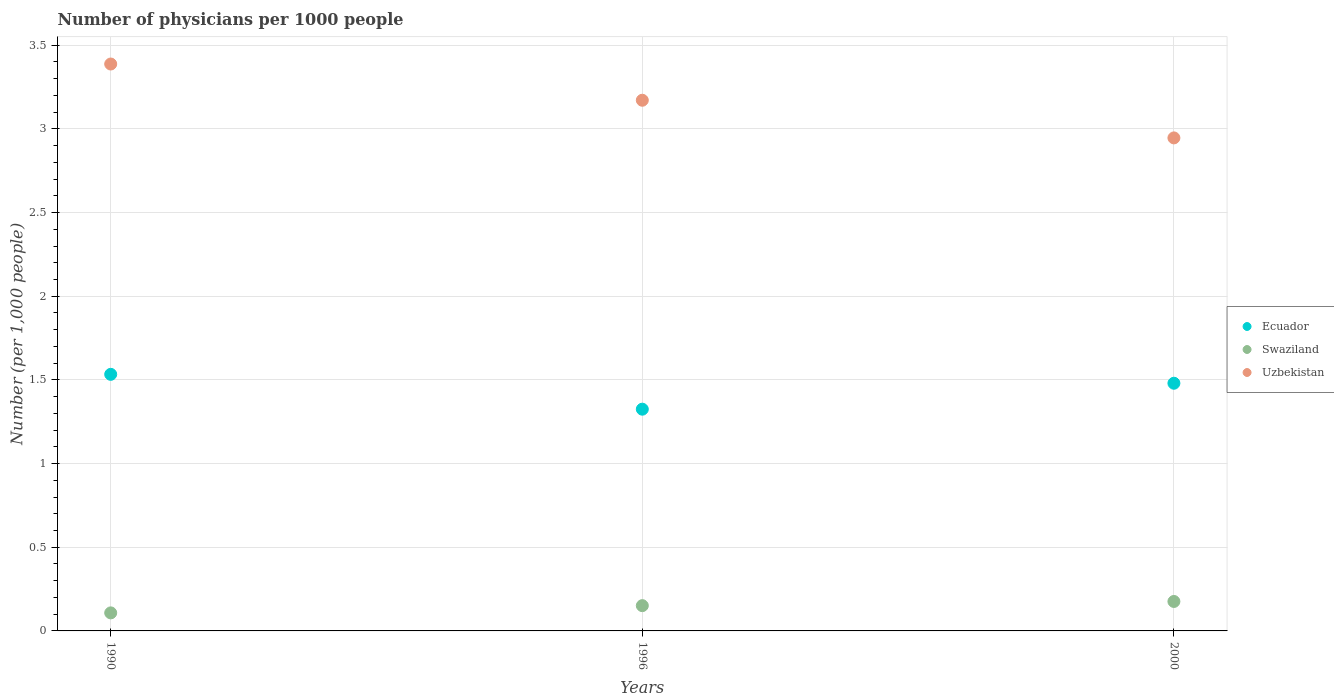How many different coloured dotlines are there?
Provide a short and direct response. 3. Is the number of dotlines equal to the number of legend labels?
Make the answer very short. Yes. What is the number of physicians in Uzbekistan in 1996?
Your answer should be very brief. 3.17. Across all years, what is the maximum number of physicians in Ecuador?
Provide a short and direct response. 1.53. Across all years, what is the minimum number of physicians in Ecuador?
Your answer should be compact. 1.32. In which year was the number of physicians in Swaziland maximum?
Give a very brief answer. 2000. What is the total number of physicians in Uzbekistan in the graph?
Make the answer very short. 9.5. What is the difference between the number of physicians in Uzbekistan in 1996 and that in 2000?
Offer a terse response. 0.22. What is the difference between the number of physicians in Swaziland in 2000 and the number of physicians in Ecuador in 1996?
Your answer should be compact. -1.15. What is the average number of physicians in Ecuador per year?
Provide a succinct answer. 1.45. In the year 1990, what is the difference between the number of physicians in Swaziland and number of physicians in Ecuador?
Your answer should be very brief. -1.43. In how many years, is the number of physicians in Uzbekistan greater than 2.7?
Your response must be concise. 3. What is the ratio of the number of physicians in Ecuador in 1996 to that in 2000?
Make the answer very short. 0.9. Is the difference between the number of physicians in Swaziland in 1990 and 1996 greater than the difference between the number of physicians in Ecuador in 1990 and 1996?
Your answer should be compact. No. What is the difference between the highest and the second highest number of physicians in Ecuador?
Provide a short and direct response. 0.05. What is the difference between the highest and the lowest number of physicians in Ecuador?
Ensure brevity in your answer.  0.21. Does the number of physicians in Swaziland monotonically increase over the years?
Offer a very short reply. Yes. Is the number of physicians in Uzbekistan strictly greater than the number of physicians in Swaziland over the years?
Your answer should be compact. Yes. Is the number of physicians in Swaziland strictly less than the number of physicians in Uzbekistan over the years?
Ensure brevity in your answer.  Yes. Does the graph contain any zero values?
Your answer should be very brief. No. Does the graph contain grids?
Give a very brief answer. Yes. Where does the legend appear in the graph?
Keep it short and to the point. Center right. What is the title of the graph?
Provide a short and direct response. Number of physicians per 1000 people. What is the label or title of the X-axis?
Your answer should be very brief. Years. What is the label or title of the Y-axis?
Your answer should be compact. Number (per 1,0 people). What is the Number (per 1,000 people) in Ecuador in 1990?
Provide a short and direct response. 1.53. What is the Number (per 1,000 people) in Swaziland in 1990?
Make the answer very short. 0.11. What is the Number (per 1,000 people) of Uzbekistan in 1990?
Provide a succinct answer. 3.39. What is the Number (per 1,000 people) in Ecuador in 1996?
Provide a short and direct response. 1.32. What is the Number (per 1,000 people) of Swaziland in 1996?
Keep it short and to the point. 0.15. What is the Number (per 1,000 people) of Uzbekistan in 1996?
Keep it short and to the point. 3.17. What is the Number (per 1,000 people) in Ecuador in 2000?
Your answer should be very brief. 1.48. What is the Number (per 1,000 people) in Swaziland in 2000?
Make the answer very short. 0.18. What is the Number (per 1,000 people) in Uzbekistan in 2000?
Give a very brief answer. 2.95. Across all years, what is the maximum Number (per 1,000 people) of Ecuador?
Your response must be concise. 1.53. Across all years, what is the maximum Number (per 1,000 people) of Swaziland?
Provide a short and direct response. 0.18. Across all years, what is the maximum Number (per 1,000 people) of Uzbekistan?
Offer a very short reply. 3.39. Across all years, what is the minimum Number (per 1,000 people) in Ecuador?
Make the answer very short. 1.32. Across all years, what is the minimum Number (per 1,000 people) of Swaziland?
Make the answer very short. 0.11. Across all years, what is the minimum Number (per 1,000 people) of Uzbekistan?
Offer a very short reply. 2.95. What is the total Number (per 1,000 people) in Ecuador in the graph?
Offer a terse response. 4.34. What is the total Number (per 1,000 people) in Swaziland in the graph?
Offer a very short reply. 0.43. What is the total Number (per 1,000 people) in Uzbekistan in the graph?
Offer a very short reply. 9.5. What is the difference between the Number (per 1,000 people) of Ecuador in 1990 and that in 1996?
Ensure brevity in your answer.  0.21. What is the difference between the Number (per 1,000 people) of Swaziland in 1990 and that in 1996?
Provide a succinct answer. -0.04. What is the difference between the Number (per 1,000 people) of Uzbekistan in 1990 and that in 1996?
Make the answer very short. 0.22. What is the difference between the Number (per 1,000 people) in Ecuador in 1990 and that in 2000?
Your response must be concise. 0.05. What is the difference between the Number (per 1,000 people) in Swaziland in 1990 and that in 2000?
Your answer should be very brief. -0.07. What is the difference between the Number (per 1,000 people) of Uzbekistan in 1990 and that in 2000?
Your answer should be very brief. 0.44. What is the difference between the Number (per 1,000 people) in Ecuador in 1996 and that in 2000?
Give a very brief answer. -0.15. What is the difference between the Number (per 1,000 people) of Swaziland in 1996 and that in 2000?
Provide a short and direct response. -0.03. What is the difference between the Number (per 1,000 people) in Uzbekistan in 1996 and that in 2000?
Your answer should be very brief. 0.23. What is the difference between the Number (per 1,000 people) in Ecuador in 1990 and the Number (per 1,000 people) in Swaziland in 1996?
Your response must be concise. 1.38. What is the difference between the Number (per 1,000 people) in Ecuador in 1990 and the Number (per 1,000 people) in Uzbekistan in 1996?
Your response must be concise. -1.64. What is the difference between the Number (per 1,000 people) in Swaziland in 1990 and the Number (per 1,000 people) in Uzbekistan in 1996?
Offer a terse response. -3.06. What is the difference between the Number (per 1,000 people) of Ecuador in 1990 and the Number (per 1,000 people) of Swaziland in 2000?
Offer a terse response. 1.36. What is the difference between the Number (per 1,000 people) of Ecuador in 1990 and the Number (per 1,000 people) of Uzbekistan in 2000?
Your answer should be compact. -1.41. What is the difference between the Number (per 1,000 people) in Swaziland in 1990 and the Number (per 1,000 people) in Uzbekistan in 2000?
Offer a very short reply. -2.84. What is the difference between the Number (per 1,000 people) in Ecuador in 1996 and the Number (per 1,000 people) in Swaziland in 2000?
Keep it short and to the point. 1.15. What is the difference between the Number (per 1,000 people) in Ecuador in 1996 and the Number (per 1,000 people) in Uzbekistan in 2000?
Offer a terse response. -1.62. What is the difference between the Number (per 1,000 people) of Swaziland in 1996 and the Number (per 1,000 people) of Uzbekistan in 2000?
Offer a very short reply. -2.79. What is the average Number (per 1,000 people) of Ecuador per year?
Your answer should be compact. 1.45. What is the average Number (per 1,000 people) of Swaziland per year?
Give a very brief answer. 0.14. What is the average Number (per 1,000 people) of Uzbekistan per year?
Keep it short and to the point. 3.17. In the year 1990, what is the difference between the Number (per 1,000 people) of Ecuador and Number (per 1,000 people) of Swaziland?
Offer a very short reply. 1.43. In the year 1990, what is the difference between the Number (per 1,000 people) in Ecuador and Number (per 1,000 people) in Uzbekistan?
Ensure brevity in your answer.  -1.85. In the year 1990, what is the difference between the Number (per 1,000 people) in Swaziland and Number (per 1,000 people) in Uzbekistan?
Ensure brevity in your answer.  -3.28. In the year 1996, what is the difference between the Number (per 1,000 people) in Ecuador and Number (per 1,000 people) in Swaziland?
Give a very brief answer. 1.17. In the year 1996, what is the difference between the Number (per 1,000 people) of Ecuador and Number (per 1,000 people) of Uzbekistan?
Provide a short and direct response. -1.85. In the year 1996, what is the difference between the Number (per 1,000 people) of Swaziland and Number (per 1,000 people) of Uzbekistan?
Your response must be concise. -3.02. In the year 2000, what is the difference between the Number (per 1,000 people) in Ecuador and Number (per 1,000 people) in Swaziland?
Give a very brief answer. 1.3. In the year 2000, what is the difference between the Number (per 1,000 people) of Ecuador and Number (per 1,000 people) of Uzbekistan?
Offer a very short reply. -1.47. In the year 2000, what is the difference between the Number (per 1,000 people) of Swaziland and Number (per 1,000 people) of Uzbekistan?
Your answer should be compact. -2.77. What is the ratio of the Number (per 1,000 people) of Ecuador in 1990 to that in 1996?
Your answer should be very brief. 1.16. What is the ratio of the Number (per 1,000 people) in Swaziland in 1990 to that in 1996?
Ensure brevity in your answer.  0.71. What is the ratio of the Number (per 1,000 people) of Uzbekistan in 1990 to that in 1996?
Make the answer very short. 1.07. What is the ratio of the Number (per 1,000 people) in Ecuador in 1990 to that in 2000?
Your response must be concise. 1.04. What is the ratio of the Number (per 1,000 people) of Swaziland in 1990 to that in 2000?
Your answer should be very brief. 0.61. What is the ratio of the Number (per 1,000 people) in Uzbekistan in 1990 to that in 2000?
Your answer should be compact. 1.15. What is the ratio of the Number (per 1,000 people) in Ecuador in 1996 to that in 2000?
Give a very brief answer. 0.9. What is the ratio of the Number (per 1,000 people) in Swaziland in 1996 to that in 2000?
Give a very brief answer. 0.86. What is the ratio of the Number (per 1,000 people) in Uzbekistan in 1996 to that in 2000?
Your response must be concise. 1.08. What is the difference between the highest and the second highest Number (per 1,000 people) in Ecuador?
Your response must be concise. 0.05. What is the difference between the highest and the second highest Number (per 1,000 people) of Swaziland?
Keep it short and to the point. 0.03. What is the difference between the highest and the second highest Number (per 1,000 people) in Uzbekistan?
Give a very brief answer. 0.22. What is the difference between the highest and the lowest Number (per 1,000 people) of Ecuador?
Your response must be concise. 0.21. What is the difference between the highest and the lowest Number (per 1,000 people) in Swaziland?
Your response must be concise. 0.07. What is the difference between the highest and the lowest Number (per 1,000 people) in Uzbekistan?
Make the answer very short. 0.44. 